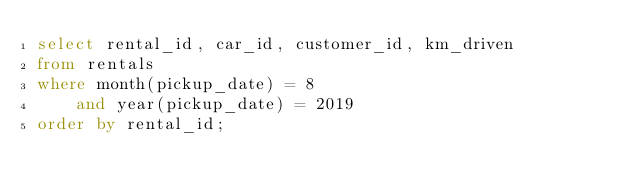<code> <loc_0><loc_0><loc_500><loc_500><_SQL_>select rental_id, car_id, customer_id, km_driven
from rentals
where month(pickup_date) = 8
    and year(pickup_date) = 2019
order by rental_id;</code> 